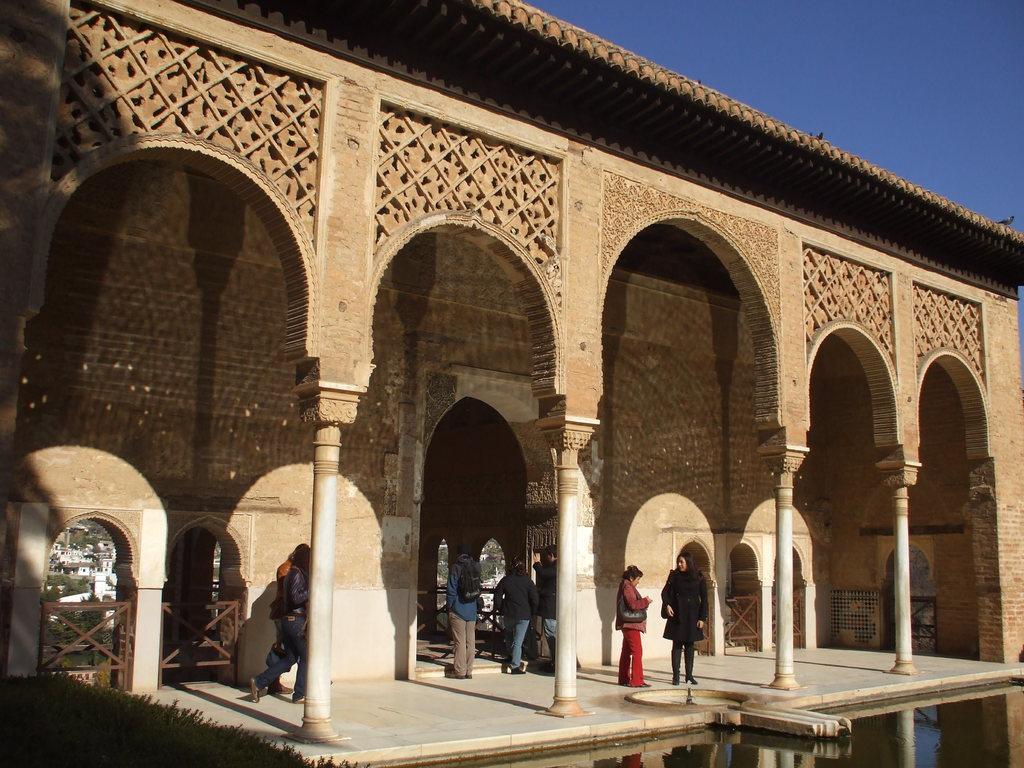What type of structure is present in the image? There is a building in the image. What colors can be seen on the building? The building has brown and white colors. What architectural features are there on the building? There are windows and pillars on the building. Who or what can be seen in the image besides the building? There are people in the image. What natural element is visible in the image? There is water visible in the image. What is the color of the sky in the image? The sky is blue in color. Can you see a game of chess being played on the roof of the building in the image? There is no roof or game of chess visible in the image. 